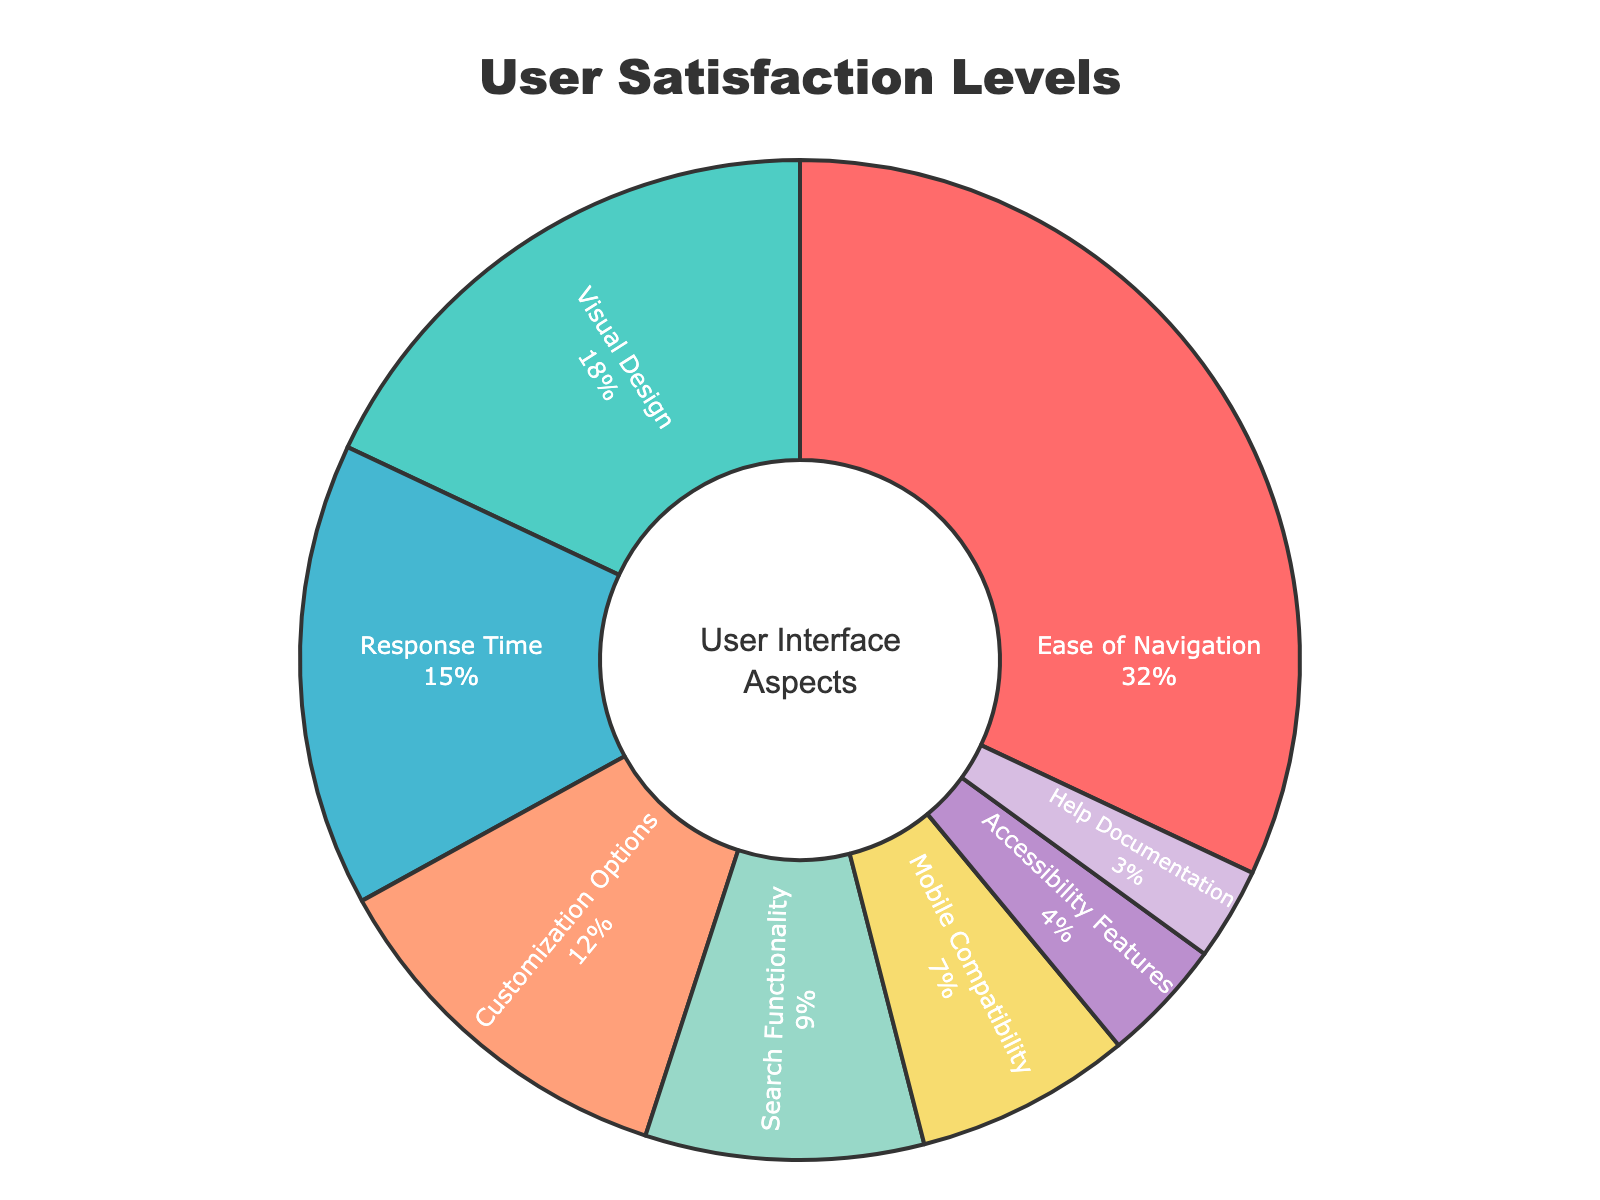What aspect has the highest user satisfaction percentage? The "Ease of Navigation" aspect has the highest satisfaction percentage, which can be identified by the largest slice size in the pie chart.
Answer: Ease of Navigation Which aspect has the lowest user satisfaction percentage? The "Help Documentation" aspect has the lowest satisfaction percentage, which is evident from the smallest slice size in the pie chart.
Answer: Help Documentation What is the total user satisfaction percentage for "Customization Options" and "Search Functionality"? Add the satisfaction percentages for "Customization Options" (12%) and "Search Functionality" (9%). Calculation: 12% + 9% = 21%.
Answer: 21% How does the user satisfaction percentage of "Ease of Navigation" compare to "Visual Design"? The satisfaction percentage for "Ease of Navigation" (32%) is greater than "Visual Design" (18%), as observed by comparing their slice sizes in the pie chart.
Answer: Ease of Navigation is greater than Visual Design What is the combined satisfaction percentage for aspects related to mobile usage and accessibility? Sum the satisfaction percentages for "Mobile Compatibility" (7%) and "Accessibility Features" (4%). Calculation: 7% + 4% = 11%.
Answer: 11% Which aspect contributes more to user satisfaction: "Response Time" or "Customization Options"? Compare the satisfaction percentages: "Response Time" (15%) is greater than "Customization Options" (12%), indicated by the larger pie slice size.
Answer: Response Time How do the satisfaction percentages for "Ease of Navigation" and "Visual Design" together compare to "Response Time" and "Customization Options" together? Add the satisfaction percentages for both pairs: (32% + 18%) vs (15% + 12%). Calculation: (32% + 18%) = 50%, (15% + 12%) = 27%. 50% is greater than 27%.
Answer: Navigation and Design are greater Which aspect has a slightly higher satisfaction percentage, "Search Functionality" or "Mobile Compatibility"? Compare the slices for "Search Functionality" (9%) and "Mobile Compatibility" (7%). "Search Functionality" has a slightly higher percentage than "Mobile Compatibility".
Answer: Search Functionality What is the mean satisfaction percentage across all aspects? Sum the satisfaction percentages for all aspects and divide by the number of aspects: (32 + 18 + 15 + 12 + 9 + 7 + 4 + 3) / 8. Calculation: (100) / 8 = 12.5%.
Answer: 12.5% Which aspect has a satisfaction percentage close to the mean value? The mean satisfaction percentage is 12.5%. "Customization Options" has a satisfaction percentage of 12%, which is closest to the mean value.
Answer: Customization Options 